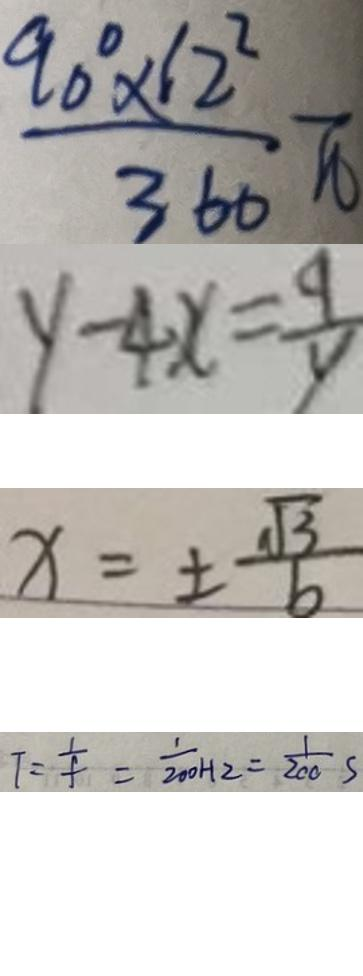<formula> <loc_0><loc_0><loc_500><loc_500>\frac { 9 0 ^ { \circ } \times 1 2 ^ { 2 } } { 3 6 0 } \pi 
 y - 4 x = \frac { 9 } { y } 
 x = \pm \frac { \sqrt { 3 } } { 6 } 
 T = \frac { 1 } { f } = \frac { 1 } { 2 0 0 H 2 } = \frac { 1 } { 2 0 0 } s</formula> 